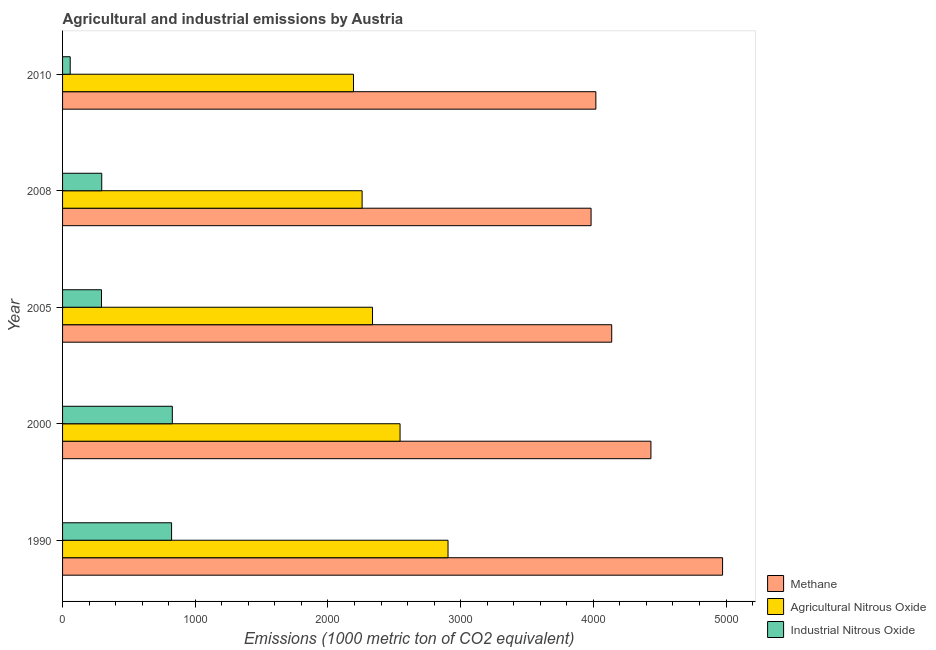How many different coloured bars are there?
Provide a succinct answer. 3. How many groups of bars are there?
Your answer should be very brief. 5. Are the number of bars on each tick of the Y-axis equal?
Provide a succinct answer. Yes. How many bars are there on the 3rd tick from the bottom?
Your answer should be compact. 3. In how many cases, is the number of bars for a given year not equal to the number of legend labels?
Keep it short and to the point. 0. What is the amount of agricultural nitrous oxide emissions in 2010?
Make the answer very short. 2192.3. Across all years, what is the maximum amount of methane emissions?
Your answer should be very brief. 4973.8. Across all years, what is the minimum amount of industrial nitrous oxide emissions?
Your answer should be compact. 57.5. In which year was the amount of methane emissions minimum?
Ensure brevity in your answer.  2008. What is the total amount of agricultural nitrous oxide emissions in the graph?
Your response must be concise. 1.22e+04. What is the difference between the amount of methane emissions in 1990 and that in 2008?
Ensure brevity in your answer.  991. What is the difference between the amount of agricultural nitrous oxide emissions in 2010 and the amount of methane emissions in 2008?
Your answer should be very brief. -1790.5. What is the average amount of methane emissions per year?
Give a very brief answer. 4309.52. In the year 2005, what is the difference between the amount of industrial nitrous oxide emissions and amount of methane emissions?
Your answer should be very brief. -3845. What is the ratio of the amount of agricultural nitrous oxide emissions in 1990 to that in 2000?
Your response must be concise. 1.14. Is the difference between the amount of methane emissions in 2000 and 2005 greater than the difference between the amount of agricultural nitrous oxide emissions in 2000 and 2005?
Your answer should be compact. Yes. What is the difference between the highest and the second highest amount of methane emissions?
Your answer should be compact. 539.9. What is the difference between the highest and the lowest amount of agricultural nitrous oxide emissions?
Offer a terse response. 712.5. What does the 3rd bar from the top in 2010 represents?
Provide a short and direct response. Methane. What does the 2nd bar from the bottom in 1990 represents?
Provide a succinct answer. Agricultural Nitrous Oxide. How many bars are there?
Keep it short and to the point. 15. What is the difference between two consecutive major ticks on the X-axis?
Your response must be concise. 1000. Does the graph contain grids?
Your answer should be very brief. No. Where does the legend appear in the graph?
Your answer should be very brief. Bottom right. How many legend labels are there?
Provide a short and direct response. 3. What is the title of the graph?
Keep it short and to the point. Agricultural and industrial emissions by Austria. What is the label or title of the X-axis?
Give a very brief answer. Emissions (1000 metric ton of CO2 equivalent). What is the Emissions (1000 metric ton of CO2 equivalent) in Methane in 1990?
Give a very brief answer. 4973.8. What is the Emissions (1000 metric ton of CO2 equivalent) of Agricultural Nitrous Oxide in 1990?
Your answer should be compact. 2904.8. What is the Emissions (1000 metric ton of CO2 equivalent) of Industrial Nitrous Oxide in 1990?
Give a very brief answer. 821.5. What is the Emissions (1000 metric ton of CO2 equivalent) in Methane in 2000?
Offer a terse response. 4433.9. What is the Emissions (1000 metric ton of CO2 equivalent) in Agricultural Nitrous Oxide in 2000?
Provide a short and direct response. 2543.3. What is the Emissions (1000 metric ton of CO2 equivalent) of Industrial Nitrous Oxide in 2000?
Give a very brief answer. 827.2. What is the Emissions (1000 metric ton of CO2 equivalent) in Methane in 2005?
Your answer should be very brief. 4138.3. What is the Emissions (1000 metric ton of CO2 equivalent) in Agricultural Nitrous Oxide in 2005?
Offer a very short reply. 2335.7. What is the Emissions (1000 metric ton of CO2 equivalent) of Industrial Nitrous Oxide in 2005?
Make the answer very short. 293.3. What is the Emissions (1000 metric ton of CO2 equivalent) of Methane in 2008?
Give a very brief answer. 3982.8. What is the Emissions (1000 metric ton of CO2 equivalent) of Agricultural Nitrous Oxide in 2008?
Your answer should be very brief. 2257.3. What is the Emissions (1000 metric ton of CO2 equivalent) in Industrial Nitrous Oxide in 2008?
Offer a terse response. 295.2. What is the Emissions (1000 metric ton of CO2 equivalent) of Methane in 2010?
Keep it short and to the point. 4018.8. What is the Emissions (1000 metric ton of CO2 equivalent) of Agricultural Nitrous Oxide in 2010?
Your answer should be very brief. 2192.3. What is the Emissions (1000 metric ton of CO2 equivalent) in Industrial Nitrous Oxide in 2010?
Give a very brief answer. 57.5. Across all years, what is the maximum Emissions (1000 metric ton of CO2 equivalent) of Methane?
Provide a succinct answer. 4973.8. Across all years, what is the maximum Emissions (1000 metric ton of CO2 equivalent) in Agricultural Nitrous Oxide?
Offer a terse response. 2904.8. Across all years, what is the maximum Emissions (1000 metric ton of CO2 equivalent) in Industrial Nitrous Oxide?
Ensure brevity in your answer.  827.2. Across all years, what is the minimum Emissions (1000 metric ton of CO2 equivalent) in Methane?
Give a very brief answer. 3982.8. Across all years, what is the minimum Emissions (1000 metric ton of CO2 equivalent) in Agricultural Nitrous Oxide?
Keep it short and to the point. 2192.3. Across all years, what is the minimum Emissions (1000 metric ton of CO2 equivalent) of Industrial Nitrous Oxide?
Keep it short and to the point. 57.5. What is the total Emissions (1000 metric ton of CO2 equivalent) in Methane in the graph?
Provide a succinct answer. 2.15e+04. What is the total Emissions (1000 metric ton of CO2 equivalent) of Agricultural Nitrous Oxide in the graph?
Keep it short and to the point. 1.22e+04. What is the total Emissions (1000 metric ton of CO2 equivalent) of Industrial Nitrous Oxide in the graph?
Your answer should be very brief. 2294.7. What is the difference between the Emissions (1000 metric ton of CO2 equivalent) of Methane in 1990 and that in 2000?
Provide a short and direct response. 539.9. What is the difference between the Emissions (1000 metric ton of CO2 equivalent) in Agricultural Nitrous Oxide in 1990 and that in 2000?
Provide a succinct answer. 361.5. What is the difference between the Emissions (1000 metric ton of CO2 equivalent) in Methane in 1990 and that in 2005?
Ensure brevity in your answer.  835.5. What is the difference between the Emissions (1000 metric ton of CO2 equivalent) of Agricultural Nitrous Oxide in 1990 and that in 2005?
Your answer should be compact. 569.1. What is the difference between the Emissions (1000 metric ton of CO2 equivalent) in Industrial Nitrous Oxide in 1990 and that in 2005?
Ensure brevity in your answer.  528.2. What is the difference between the Emissions (1000 metric ton of CO2 equivalent) in Methane in 1990 and that in 2008?
Your answer should be very brief. 991. What is the difference between the Emissions (1000 metric ton of CO2 equivalent) of Agricultural Nitrous Oxide in 1990 and that in 2008?
Provide a short and direct response. 647.5. What is the difference between the Emissions (1000 metric ton of CO2 equivalent) in Industrial Nitrous Oxide in 1990 and that in 2008?
Ensure brevity in your answer.  526.3. What is the difference between the Emissions (1000 metric ton of CO2 equivalent) in Methane in 1990 and that in 2010?
Provide a succinct answer. 955. What is the difference between the Emissions (1000 metric ton of CO2 equivalent) in Agricultural Nitrous Oxide in 1990 and that in 2010?
Provide a succinct answer. 712.5. What is the difference between the Emissions (1000 metric ton of CO2 equivalent) in Industrial Nitrous Oxide in 1990 and that in 2010?
Your answer should be compact. 764. What is the difference between the Emissions (1000 metric ton of CO2 equivalent) of Methane in 2000 and that in 2005?
Offer a terse response. 295.6. What is the difference between the Emissions (1000 metric ton of CO2 equivalent) in Agricultural Nitrous Oxide in 2000 and that in 2005?
Ensure brevity in your answer.  207.6. What is the difference between the Emissions (1000 metric ton of CO2 equivalent) in Industrial Nitrous Oxide in 2000 and that in 2005?
Offer a very short reply. 533.9. What is the difference between the Emissions (1000 metric ton of CO2 equivalent) of Methane in 2000 and that in 2008?
Your response must be concise. 451.1. What is the difference between the Emissions (1000 metric ton of CO2 equivalent) in Agricultural Nitrous Oxide in 2000 and that in 2008?
Offer a terse response. 286. What is the difference between the Emissions (1000 metric ton of CO2 equivalent) of Industrial Nitrous Oxide in 2000 and that in 2008?
Offer a terse response. 532. What is the difference between the Emissions (1000 metric ton of CO2 equivalent) of Methane in 2000 and that in 2010?
Offer a terse response. 415.1. What is the difference between the Emissions (1000 metric ton of CO2 equivalent) in Agricultural Nitrous Oxide in 2000 and that in 2010?
Your answer should be very brief. 351. What is the difference between the Emissions (1000 metric ton of CO2 equivalent) of Industrial Nitrous Oxide in 2000 and that in 2010?
Your response must be concise. 769.7. What is the difference between the Emissions (1000 metric ton of CO2 equivalent) of Methane in 2005 and that in 2008?
Provide a short and direct response. 155.5. What is the difference between the Emissions (1000 metric ton of CO2 equivalent) of Agricultural Nitrous Oxide in 2005 and that in 2008?
Keep it short and to the point. 78.4. What is the difference between the Emissions (1000 metric ton of CO2 equivalent) of Industrial Nitrous Oxide in 2005 and that in 2008?
Provide a short and direct response. -1.9. What is the difference between the Emissions (1000 metric ton of CO2 equivalent) of Methane in 2005 and that in 2010?
Your response must be concise. 119.5. What is the difference between the Emissions (1000 metric ton of CO2 equivalent) in Agricultural Nitrous Oxide in 2005 and that in 2010?
Your answer should be very brief. 143.4. What is the difference between the Emissions (1000 metric ton of CO2 equivalent) in Industrial Nitrous Oxide in 2005 and that in 2010?
Make the answer very short. 235.8. What is the difference between the Emissions (1000 metric ton of CO2 equivalent) of Methane in 2008 and that in 2010?
Your answer should be very brief. -36. What is the difference between the Emissions (1000 metric ton of CO2 equivalent) in Agricultural Nitrous Oxide in 2008 and that in 2010?
Offer a terse response. 65. What is the difference between the Emissions (1000 metric ton of CO2 equivalent) in Industrial Nitrous Oxide in 2008 and that in 2010?
Give a very brief answer. 237.7. What is the difference between the Emissions (1000 metric ton of CO2 equivalent) in Methane in 1990 and the Emissions (1000 metric ton of CO2 equivalent) in Agricultural Nitrous Oxide in 2000?
Your answer should be very brief. 2430.5. What is the difference between the Emissions (1000 metric ton of CO2 equivalent) in Methane in 1990 and the Emissions (1000 metric ton of CO2 equivalent) in Industrial Nitrous Oxide in 2000?
Give a very brief answer. 4146.6. What is the difference between the Emissions (1000 metric ton of CO2 equivalent) in Agricultural Nitrous Oxide in 1990 and the Emissions (1000 metric ton of CO2 equivalent) in Industrial Nitrous Oxide in 2000?
Your answer should be compact. 2077.6. What is the difference between the Emissions (1000 metric ton of CO2 equivalent) of Methane in 1990 and the Emissions (1000 metric ton of CO2 equivalent) of Agricultural Nitrous Oxide in 2005?
Keep it short and to the point. 2638.1. What is the difference between the Emissions (1000 metric ton of CO2 equivalent) of Methane in 1990 and the Emissions (1000 metric ton of CO2 equivalent) of Industrial Nitrous Oxide in 2005?
Make the answer very short. 4680.5. What is the difference between the Emissions (1000 metric ton of CO2 equivalent) in Agricultural Nitrous Oxide in 1990 and the Emissions (1000 metric ton of CO2 equivalent) in Industrial Nitrous Oxide in 2005?
Your answer should be compact. 2611.5. What is the difference between the Emissions (1000 metric ton of CO2 equivalent) in Methane in 1990 and the Emissions (1000 metric ton of CO2 equivalent) in Agricultural Nitrous Oxide in 2008?
Give a very brief answer. 2716.5. What is the difference between the Emissions (1000 metric ton of CO2 equivalent) of Methane in 1990 and the Emissions (1000 metric ton of CO2 equivalent) of Industrial Nitrous Oxide in 2008?
Your answer should be very brief. 4678.6. What is the difference between the Emissions (1000 metric ton of CO2 equivalent) of Agricultural Nitrous Oxide in 1990 and the Emissions (1000 metric ton of CO2 equivalent) of Industrial Nitrous Oxide in 2008?
Make the answer very short. 2609.6. What is the difference between the Emissions (1000 metric ton of CO2 equivalent) of Methane in 1990 and the Emissions (1000 metric ton of CO2 equivalent) of Agricultural Nitrous Oxide in 2010?
Offer a very short reply. 2781.5. What is the difference between the Emissions (1000 metric ton of CO2 equivalent) of Methane in 1990 and the Emissions (1000 metric ton of CO2 equivalent) of Industrial Nitrous Oxide in 2010?
Make the answer very short. 4916.3. What is the difference between the Emissions (1000 metric ton of CO2 equivalent) of Agricultural Nitrous Oxide in 1990 and the Emissions (1000 metric ton of CO2 equivalent) of Industrial Nitrous Oxide in 2010?
Give a very brief answer. 2847.3. What is the difference between the Emissions (1000 metric ton of CO2 equivalent) in Methane in 2000 and the Emissions (1000 metric ton of CO2 equivalent) in Agricultural Nitrous Oxide in 2005?
Make the answer very short. 2098.2. What is the difference between the Emissions (1000 metric ton of CO2 equivalent) of Methane in 2000 and the Emissions (1000 metric ton of CO2 equivalent) of Industrial Nitrous Oxide in 2005?
Keep it short and to the point. 4140.6. What is the difference between the Emissions (1000 metric ton of CO2 equivalent) in Agricultural Nitrous Oxide in 2000 and the Emissions (1000 metric ton of CO2 equivalent) in Industrial Nitrous Oxide in 2005?
Give a very brief answer. 2250. What is the difference between the Emissions (1000 metric ton of CO2 equivalent) of Methane in 2000 and the Emissions (1000 metric ton of CO2 equivalent) of Agricultural Nitrous Oxide in 2008?
Offer a very short reply. 2176.6. What is the difference between the Emissions (1000 metric ton of CO2 equivalent) in Methane in 2000 and the Emissions (1000 metric ton of CO2 equivalent) in Industrial Nitrous Oxide in 2008?
Your answer should be compact. 4138.7. What is the difference between the Emissions (1000 metric ton of CO2 equivalent) in Agricultural Nitrous Oxide in 2000 and the Emissions (1000 metric ton of CO2 equivalent) in Industrial Nitrous Oxide in 2008?
Make the answer very short. 2248.1. What is the difference between the Emissions (1000 metric ton of CO2 equivalent) in Methane in 2000 and the Emissions (1000 metric ton of CO2 equivalent) in Agricultural Nitrous Oxide in 2010?
Make the answer very short. 2241.6. What is the difference between the Emissions (1000 metric ton of CO2 equivalent) in Methane in 2000 and the Emissions (1000 metric ton of CO2 equivalent) in Industrial Nitrous Oxide in 2010?
Offer a very short reply. 4376.4. What is the difference between the Emissions (1000 metric ton of CO2 equivalent) in Agricultural Nitrous Oxide in 2000 and the Emissions (1000 metric ton of CO2 equivalent) in Industrial Nitrous Oxide in 2010?
Offer a terse response. 2485.8. What is the difference between the Emissions (1000 metric ton of CO2 equivalent) of Methane in 2005 and the Emissions (1000 metric ton of CO2 equivalent) of Agricultural Nitrous Oxide in 2008?
Your response must be concise. 1881. What is the difference between the Emissions (1000 metric ton of CO2 equivalent) of Methane in 2005 and the Emissions (1000 metric ton of CO2 equivalent) of Industrial Nitrous Oxide in 2008?
Your response must be concise. 3843.1. What is the difference between the Emissions (1000 metric ton of CO2 equivalent) of Agricultural Nitrous Oxide in 2005 and the Emissions (1000 metric ton of CO2 equivalent) of Industrial Nitrous Oxide in 2008?
Keep it short and to the point. 2040.5. What is the difference between the Emissions (1000 metric ton of CO2 equivalent) of Methane in 2005 and the Emissions (1000 metric ton of CO2 equivalent) of Agricultural Nitrous Oxide in 2010?
Provide a succinct answer. 1946. What is the difference between the Emissions (1000 metric ton of CO2 equivalent) of Methane in 2005 and the Emissions (1000 metric ton of CO2 equivalent) of Industrial Nitrous Oxide in 2010?
Make the answer very short. 4080.8. What is the difference between the Emissions (1000 metric ton of CO2 equivalent) of Agricultural Nitrous Oxide in 2005 and the Emissions (1000 metric ton of CO2 equivalent) of Industrial Nitrous Oxide in 2010?
Offer a terse response. 2278.2. What is the difference between the Emissions (1000 metric ton of CO2 equivalent) of Methane in 2008 and the Emissions (1000 metric ton of CO2 equivalent) of Agricultural Nitrous Oxide in 2010?
Your answer should be very brief. 1790.5. What is the difference between the Emissions (1000 metric ton of CO2 equivalent) of Methane in 2008 and the Emissions (1000 metric ton of CO2 equivalent) of Industrial Nitrous Oxide in 2010?
Offer a terse response. 3925.3. What is the difference between the Emissions (1000 metric ton of CO2 equivalent) of Agricultural Nitrous Oxide in 2008 and the Emissions (1000 metric ton of CO2 equivalent) of Industrial Nitrous Oxide in 2010?
Keep it short and to the point. 2199.8. What is the average Emissions (1000 metric ton of CO2 equivalent) in Methane per year?
Offer a very short reply. 4309.52. What is the average Emissions (1000 metric ton of CO2 equivalent) of Agricultural Nitrous Oxide per year?
Your response must be concise. 2446.68. What is the average Emissions (1000 metric ton of CO2 equivalent) in Industrial Nitrous Oxide per year?
Provide a succinct answer. 458.94. In the year 1990, what is the difference between the Emissions (1000 metric ton of CO2 equivalent) of Methane and Emissions (1000 metric ton of CO2 equivalent) of Agricultural Nitrous Oxide?
Your response must be concise. 2069. In the year 1990, what is the difference between the Emissions (1000 metric ton of CO2 equivalent) in Methane and Emissions (1000 metric ton of CO2 equivalent) in Industrial Nitrous Oxide?
Give a very brief answer. 4152.3. In the year 1990, what is the difference between the Emissions (1000 metric ton of CO2 equivalent) of Agricultural Nitrous Oxide and Emissions (1000 metric ton of CO2 equivalent) of Industrial Nitrous Oxide?
Ensure brevity in your answer.  2083.3. In the year 2000, what is the difference between the Emissions (1000 metric ton of CO2 equivalent) in Methane and Emissions (1000 metric ton of CO2 equivalent) in Agricultural Nitrous Oxide?
Provide a short and direct response. 1890.6. In the year 2000, what is the difference between the Emissions (1000 metric ton of CO2 equivalent) of Methane and Emissions (1000 metric ton of CO2 equivalent) of Industrial Nitrous Oxide?
Give a very brief answer. 3606.7. In the year 2000, what is the difference between the Emissions (1000 metric ton of CO2 equivalent) in Agricultural Nitrous Oxide and Emissions (1000 metric ton of CO2 equivalent) in Industrial Nitrous Oxide?
Provide a succinct answer. 1716.1. In the year 2005, what is the difference between the Emissions (1000 metric ton of CO2 equivalent) in Methane and Emissions (1000 metric ton of CO2 equivalent) in Agricultural Nitrous Oxide?
Ensure brevity in your answer.  1802.6. In the year 2005, what is the difference between the Emissions (1000 metric ton of CO2 equivalent) in Methane and Emissions (1000 metric ton of CO2 equivalent) in Industrial Nitrous Oxide?
Provide a short and direct response. 3845. In the year 2005, what is the difference between the Emissions (1000 metric ton of CO2 equivalent) of Agricultural Nitrous Oxide and Emissions (1000 metric ton of CO2 equivalent) of Industrial Nitrous Oxide?
Ensure brevity in your answer.  2042.4. In the year 2008, what is the difference between the Emissions (1000 metric ton of CO2 equivalent) of Methane and Emissions (1000 metric ton of CO2 equivalent) of Agricultural Nitrous Oxide?
Your answer should be very brief. 1725.5. In the year 2008, what is the difference between the Emissions (1000 metric ton of CO2 equivalent) in Methane and Emissions (1000 metric ton of CO2 equivalent) in Industrial Nitrous Oxide?
Provide a succinct answer. 3687.6. In the year 2008, what is the difference between the Emissions (1000 metric ton of CO2 equivalent) of Agricultural Nitrous Oxide and Emissions (1000 metric ton of CO2 equivalent) of Industrial Nitrous Oxide?
Ensure brevity in your answer.  1962.1. In the year 2010, what is the difference between the Emissions (1000 metric ton of CO2 equivalent) in Methane and Emissions (1000 metric ton of CO2 equivalent) in Agricultural Nitrous Oxide?
Your answer should be very brief. 1826.5. In the year 2010, what is the difference between the Emissions (1000 metric ton of CO2 equivalent) of Methane and Emissions (1000 metric ton of CO2 equivalent) of Industrial Nitrous Oxide?
Your answer should be compact. 3961.3. In the year 2010, what is the difference between the Emissions (1000 metric ton of CO2 equivalent) in Agricultural Nitrous Oxide and Emissions (1000 metric ton of CO2 equivalent) in Industrial Nitrous Oxide?
Keep it short and to the point. 2134.8. What is the ratio of the Emissions (1000 metric ton of CO2 equivalent) in Methane in 1990 to that in 2000?
Make the answer very short. 1.12. What is the ratio of the Emissions (1000 metric ton of CO2 equivalent) in Agricultural Nitrous Oxide in 1990 to that in 2000?
Your answer should be compact. 1.14. What is the ratio of the Emissions (1000 metric ton of CO2 equivalent) in Methane in 1990 to that in 2005?
Keep it short and to the point. 1.2. What is the ratio of the Emissions (1000 metric ton of CO2 equivalent) of Agricultural Nitrous Oxide in 1990 to that in 2005?
Your answer should be compact. 1.24. What is the ratio of the Emissions (1000 metric ton of CO2 equivalent) of Industrial Nitrous Oxide in 1990 to that in 2005?
Ensure brevity in your answer.  2.8. What is the ratio of the Emissions (1000 metric ton of CO2 equivalent) of Methane in 1990 to that in 2008?
Your response must be concise. 1.25. What is the ratio of the Emissions (1000 metric ton of CO2 equivalent) of Agricultural Nitrous Oxide in 1990 to that in 2008?
Your response must be concise. 1.29. What is the ratio of the Emissions (1000 metric ton of CO2 equivalent) in Industrial Nitrous Oxide in 1990 to that in 2008?
Keep it short and to the point. 2.78. What is the ratio of the Emissions (1000 metric ton of CO2 equivalent) of Methane in 1990 to that in 2010?
Ensure brevity in your answer.  1.24. What is the ratio of the Emissions (1000 metric ton of CO2 equivalent) in Agricultural Nitrous Oxide in 1990 to that in 2010?
Provide a short and direct response. 1.32. What is the ratio of the Emissions (1000 metric ton of CO2 equivalent) of Industrial Nitrous Oxide in 1990 to that in 2010?
Make the answer very short. 14.29. What is the ratio of the Emissions (1000 metric ton of CO2 equivalent) in Methane in 2000 to that in 2005?
Offer a very short reply. 1.07. What is the ratio of the Emissions (1000 metric ton of CO2 equivalent) in Agricultural Nitrous Oxide in 2000 to that in 2005?
Your answer should be compact. 1.09. What is the ratio of the Emissions (1000 metric ton of CO2 equivalent) in Industrial Nitrous Oxide in 2000 to that in 2005?
Your response must be concise. 2.82. What is the ratio of the Emissions (1000 metric ton of CO2 equivalent) of Methane in 2000 to that in 2008?
Offer a terse response. 1.11. What is the ratio of the Emissions (1000 metric ton of CO2 equivalent) of Agricultural Nitrous Oxide in 2000 to that in 2008?
Keep it short and to the point. 1.13. What is the ratio of the Emissions (1000 metric ton of CO2 equivalent) in Industrial Nitrous Oxide in 2000 to that in 2008?
Give a very brief answer. 2.8. What is the ratio of the Emissions (1000 metric ton of CO2 equivalent) in Methane in 2000 to that in 2010?
Keep it short and to the point. 1.1. What is the ratio of the Emissions (1000 metric ton of CO2 equivalent) of Agricultural Nitrous Oxide in 2000 to that in 2010?
Your response must be concise. 1.16. What is the ratio of the Emissions (1000 metric ton of CO2 equivalent) in Industrial Nitrous Oxide in 2000 to that in 2010?
Offer a very short reply. 14.39. What is the ratio of the Emissions (1000 metric ton of CO2 equivalent) of Methane in 2005 to that in 2008?
Your answer should be very brief. 1.04. What is the ratio of the Emissions (1000 metric ton of CO2 equivalent) of Agricultural Nitrous Oxide in 2005 to that in 2008?
Give a very brief answer. 1.03. What is the ratio of the Emissions (1000 metric ton of CO2 equivalent) in Industrial Nitrous Oxide in 2005 to that in 2008?
Offer a terse response. 0.99. What is the ratio of the Emissions (1000 metric ton of CO2 equivalent) in Methane in 2005 to that in 2010?
Ensure brevity in your answer.  1.03. What is the ratio of the Emissions (1000 metric ton of CO2 equivalent) in Agricultural Nitrous Oxide in 2005 to that in 2010?
Your answer should be compact. 1.07. What is the ratio of the Emissions (1000 metric ton of CO2 equivalent) in Industrial Nitrous Oxide in 2005 to that in 2010?
Keep it short and to the point. 5.1. What is the ratio of the Emissions (1000 metric ton of CO2 equivalent) in Agricultural Nitrous Oxide in 2008 to that in 2010?
Your response must be concise. 1.03. What is the ratio of the Emissions (1000 metric ton of CO2 equivalent) in Industrial Nitrous Oxide in 2008 to that in 2010?
Provide a succinct answer. 5.13. What is the difference between the highest and the second highest Emissions (1000 metric ton of CO2 equivalent) in Methane?
Give a very brief answer. 539.9. What is the difference between the highest and the second highest Emissions (1000 metric ton of CO2 equivalent) in Agricultural Nitrous Oxide?
Give a very brief answer. 361.5. What is the difference between the highest and the second highest Emissions (1000 metric ton of CO2 equivalent) of Industrial Nitrous Oxide?
Your response must be concise. 5.7. What is the difference between the highest and the lowest Emissions (1000 metric ton of CO2 equivalent) in Methane?
Your answer should be compact. 991. What is the difference between the highest and the lowest Emissions (1000 metric ton of CO2 equivalent) in Agricultural Nitrous Oxide?
Your answer should be compact. 712.5. What is the difference between the highest and the lowest Emissions (1000 metric ton of CO2 equivalent) in Industrial Nitrous Oxide?
Your answer should be very brief. 769.7. 